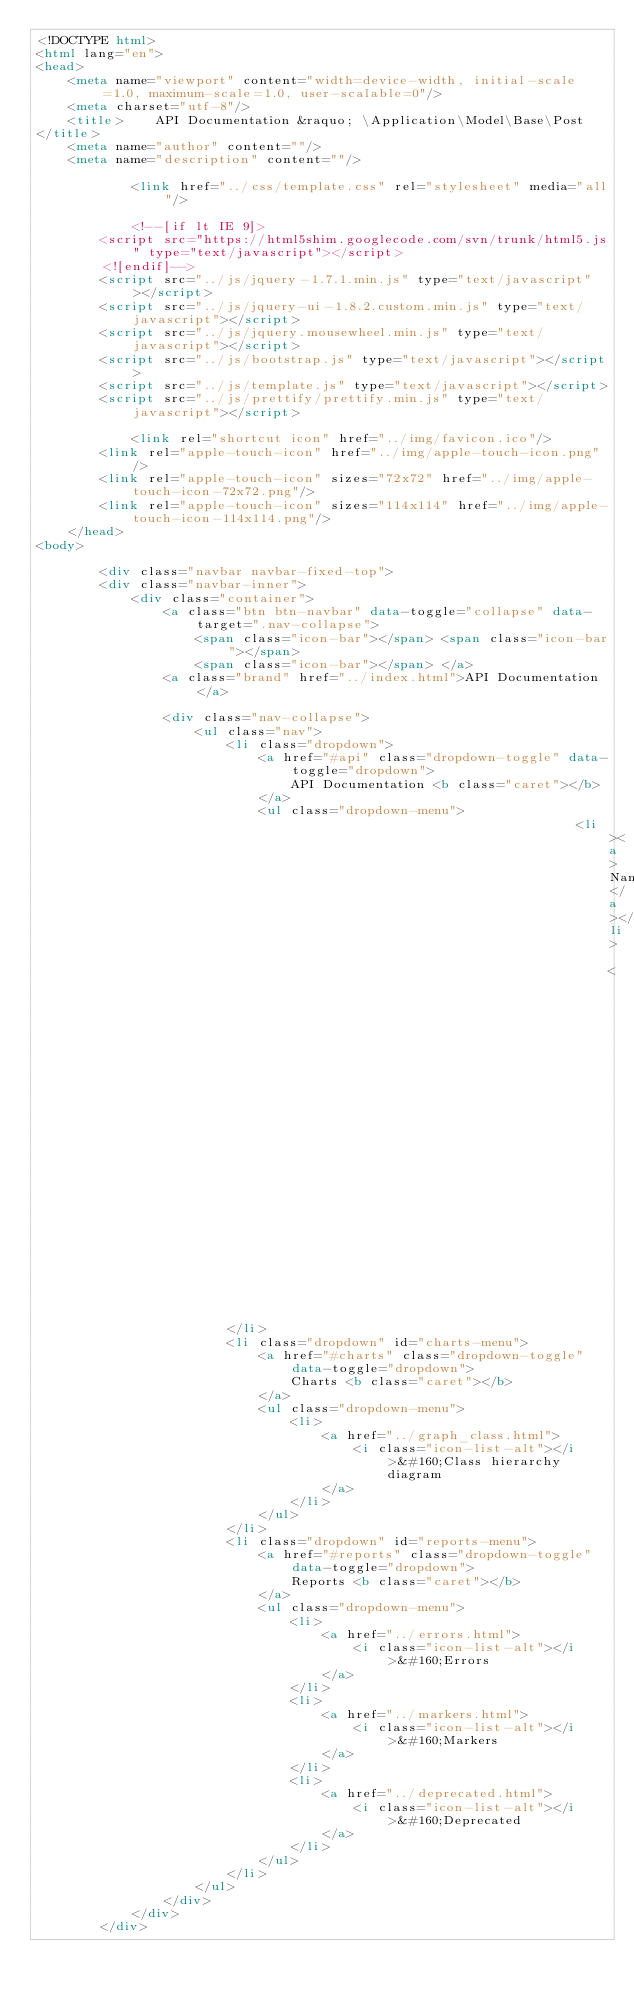Convert code to text. <code><loc_0><loc_0><loc_500><loc_500><_HTML_><!DOCTYPE html>
<html lang="en">
<head>
    <meta name="viewport" content="width=device-width, initial-scale=1.0, maximum-scale=1.0, user-scalable=0"/>
    <meta charset="utf-8"/>
    <title>    API Documentation &raquo; \Application\Model\Base\Post
</title>
    <meta name="author" content=""/>
    <meta name="description" content=""/>

            <link href="../css/template.css" rel="stylesheet" media="all"/>
    
            <!--[if lt IE 9]>
        <script src="https://html5shim.googlecode.com/svn/trunk/html5.js" type="text/javascript"></script>
        <![endif]-->
        <script src="../js/jquery-1.7.1.min.js" type="text/javascript"></script>
        <script src="../js/jquery-ui-1.8.2.custom.min.js" type="text/javascript"></script>
        <script src="../js/jquery.mousewheel.min.js" type="text/javascript"></script>
        <script src="../js/bootstrap.js" type="text/javascript"></script>
        <script src="../js/template.js" type="text/javascript"></script>
        <script src="../js/prettify/prettify.min.js" type="text/javascript"></script>
    
            <link rel="shortcut icon" href="../img/favicon.ico"/>
        <link rel="apple-touch-icon" href="../img/apple-touch-icon.png"/>
        <link rel="apple-touch-icon" sizes="72x72" href="../img/apple-touch-icon-72x72.png"/>
        <link rel="apple-touch-icon" sizes="114x114" href="../img/apple-touch-icon-114x114.png"/>
    </head>
<body>

        <div class="navbar navbar-fixed-top">
        <div class="navbar-inner">
            <div class="container">
                <a class="btn btn-navbar" data-toggle="collapse" data-target=".nav-collapse">
                    <span class="icon-bar"></span> <span class="icon-bar"></span>
                    <span class="icon-bar"></span> </a>
                <a class="brand" href="../index.html">API Documentation</a>

                <div class="nav-collapse">
                    <ul class="nav">
                        <li class="dropdown">
                            <a href="#api" class="dropdown-toggle" data-toggle="dropdown">
                                API Documentation <b class="caret"></b>
                            </a>
                            <ul class="dropdown-menu">
                                                                    <li><a>Namespaces</a></li>
                                                                        <li><a href="../namespaces/Application.html">Application</a></li>
                                                                                                                                </ul>
                        </li>
                        <li class="dropdown" id="charts-menu">
                            <a href="#charts" class="dropdown-toggle" data-toggle="dropdown">
                                Charts <b class="caret"></b>
                            </a>
                            <ul class="dropdown-menu">
                                <li>
                                    <a href="../graph_class.html">
                                        <i class="icon-list-alt"></i>&#160;Class hierarchy diagram
                                    </a>
                                </li>
                            </ul>
                        </li>
                        <li class="dropdown" id="reports-menu">
                            <a href="#reports" class="dropdown-toggle" data-toggle="dropdown">
                                Reports <b class="caret"></b>
                            </a>
                            <ul class="dropdown-menu">
                                <li>
                                    <a href="../errors.html">
                                        <i class="icon-list-alt"></i>&#160;Errors
                                    </a>
                                </li>
                                <li>
                                    <a href="../markers.html">
                                        <i class="icon-list-alt"></i>&#160;Markers
                                    </a>
                                </li>
                                <li>
                                    <a href="../deprecated.html">
                                        <i class="icon-list-alt"></i>&#160;Deprecated
                                    </a>
                                </li>
                            </ul>
                        </li>
                    </ul>
                </div>
            </div>
        </div></code> 